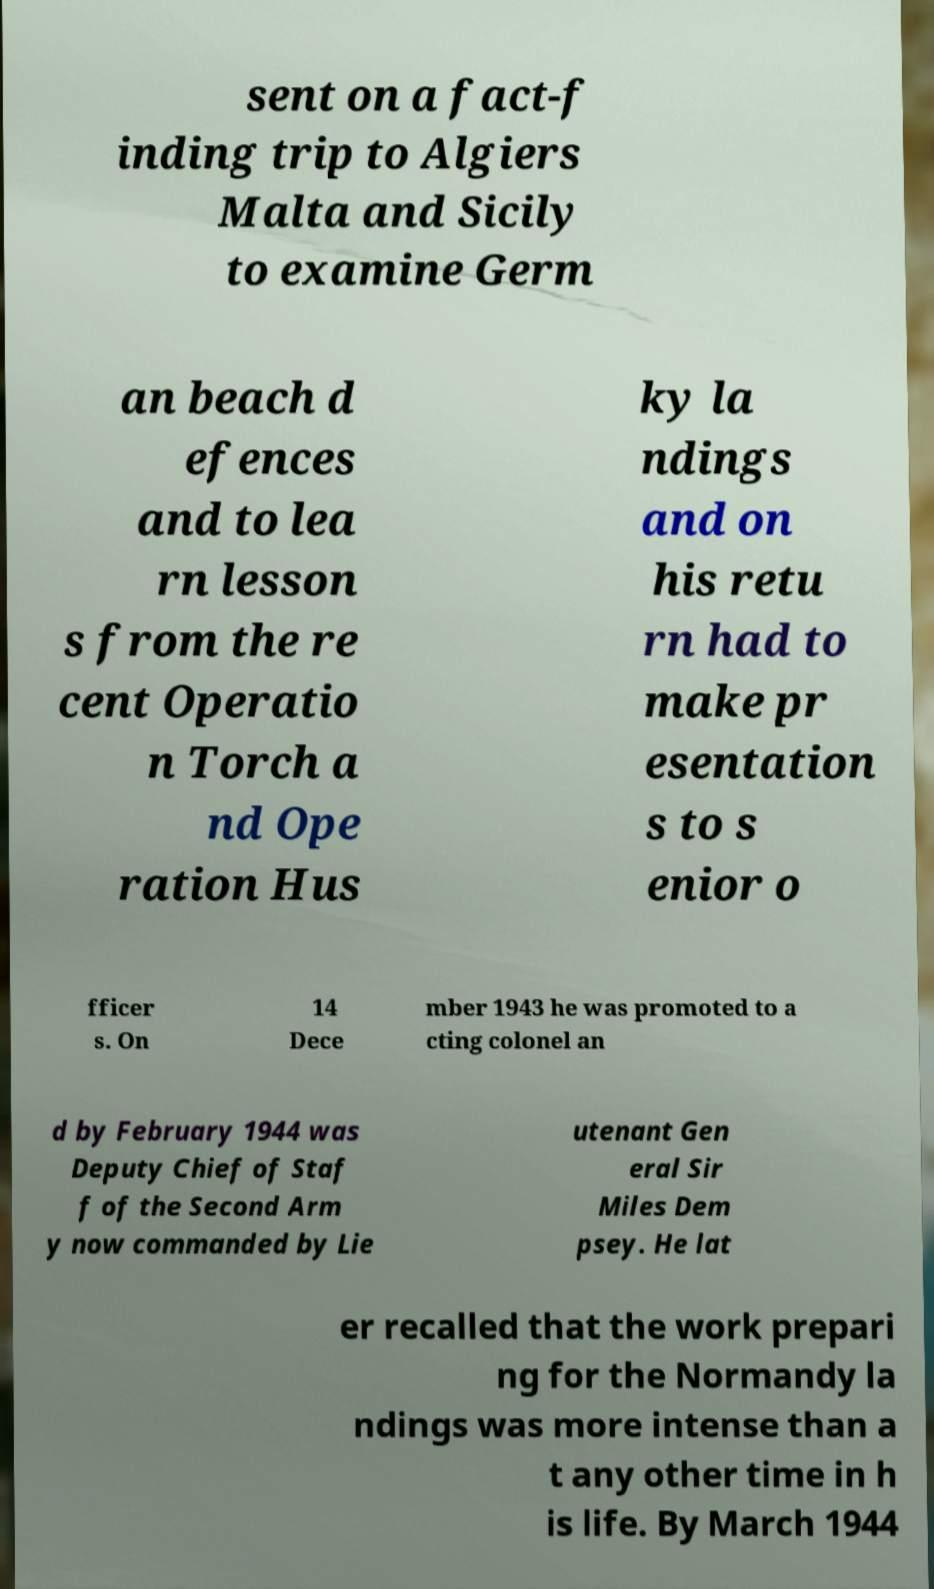Please read and relay the text visible in this image. What does it say? sent on a fact-f inding trip to Algiers Malta and Sicily to examine Germ an beach d efences and to lea rn lesson s from the re cent Operatio n Torch a nd Ope ration Hus ky la ndings and on his retu rn had to make pr esentation s to s enior o fficer s. On 14 Dece mber 1943 he was promoted to a cting colonel an d by February 1944 was Deputy Chief of Staf f of the Second Arm y now commanded by Lie utenant Gen eral Sir Miles Dem psey. He lat er recalled that the work prepari ng for the Normandy la ndings was more intense than a t any other time in h is life. By March 1944 